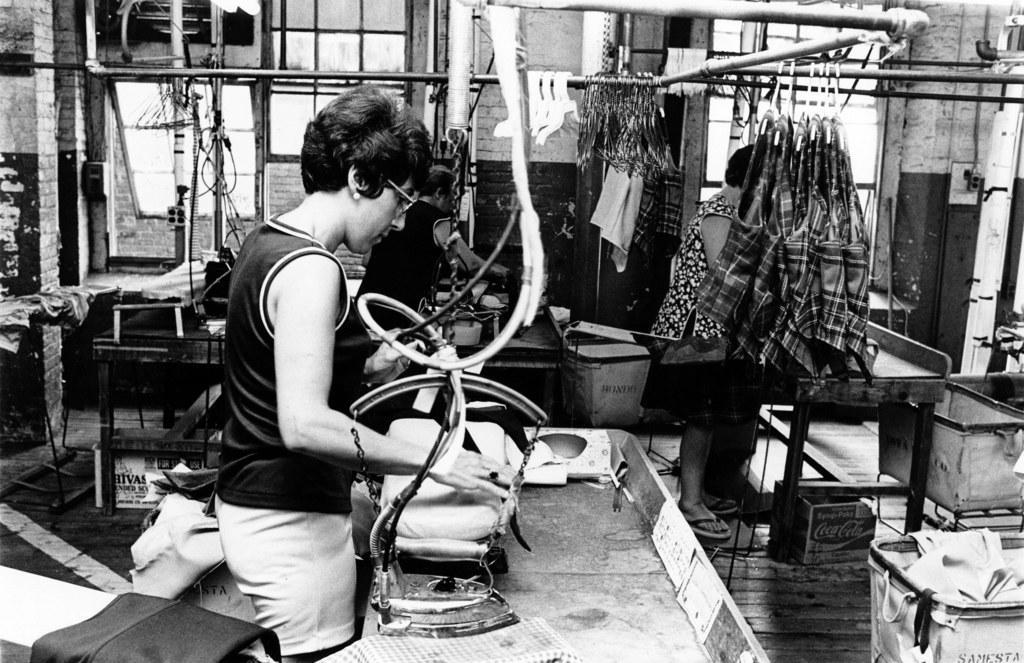How would you summarize this image in a sentence or two? In this black and white picture there is a woman standing. In front of her there is table. On the table there are clothes and a iron box. There are cardboard boxes and trolleys on the floor. There are dressed to the hangers. In the background there is a wall. There are windows to the wall. 